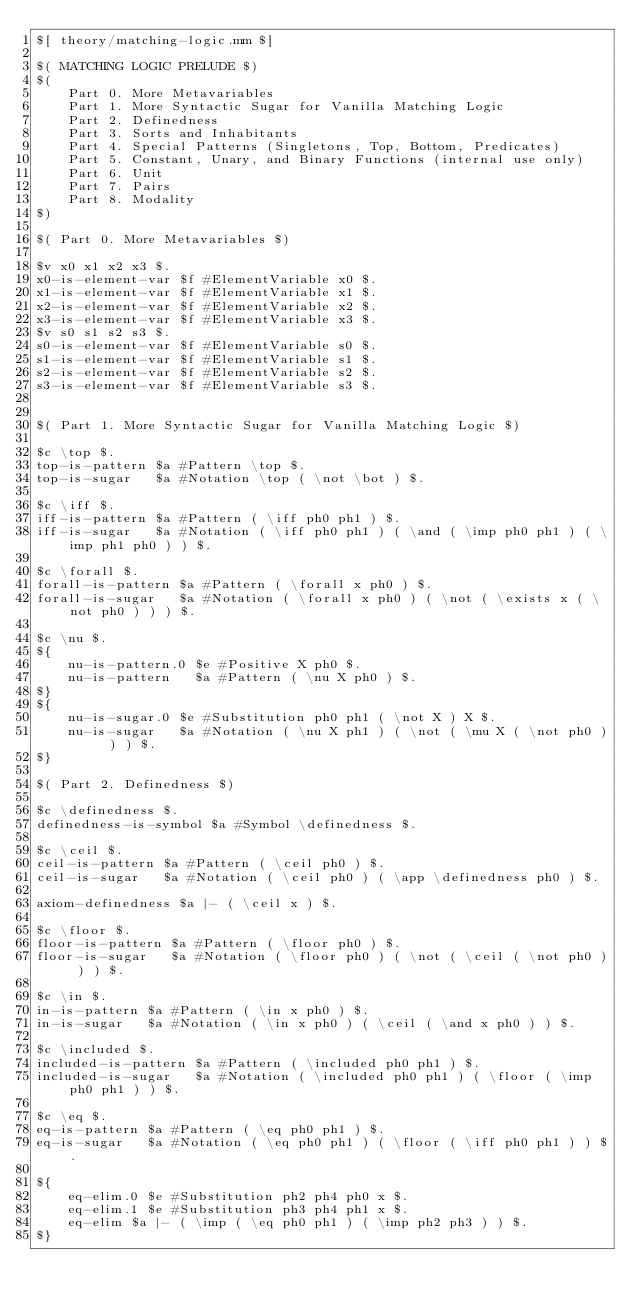<code> <loc_0><loc_0><loc_500><loc_500><_ObjectiveC_>$[ theory/matching-logic.mm $]

$( MATCHING LOGIC PRELUDE $)
$(
    Part 0. More Metavariables
    Part 1. More Syntactic Sugar for Vanilla Matching Logic
    Part 2. Definedness
    Part 3. Sorts and Inhabitants
    Part 4. Special Patterns (Singletons, Top, Bottom, Predicates)
    Part 5. Constant, Unary, and Binary Functions (internal use only)
    Part 6. Unit
    Part 7. Pairs
    Part 8. Modality
$)

$( Part 0. More Metavariables $)

$v x0 x1 x2 x3 $.
x0-is-element-var $f #ElementVariable x0 $.
x1-is-element-var $f #ElementVariable x1 $.
x2-is-element-var $f #ElementVariable x2 $.
x3-is-element-var $f #ElementVariable x3 $.
$v s0 s1 s2 s3 $.
s0-is-element-var $f #ElementVariable s0 $.
s1-is-element-var $f #ElementVariable s1 $.
s2-is-element-var $f #ElementVariable s2 $.
s3-is-element-var $f #ElementVariable s3 $.


$( Part 1. More Syntactic Sugar for Vanilla Matching Logic $)

$c \top $.
top-is-pattern $a #Pattern \top $.
top-is-sugar   $a #Notation \top ( \not \bot ) $.

$c \iff $.
iff-is-pattern $a #Pattern ( \iff ph0 ph1 ) $.
iff-is-sugar   $a #Notation ( \iff ph0 ph1 ) ( \and ( \imp ph0 ph1 ) ( \imp ph1 ph0 ) ) $.

$c \forall $.
forall-is-pattern $a #Pattern ( \forall x ph0 ) $.
forall-is-sugar   $a #Notation ( \forall x ph0 ) ( \not ( \exists x ( \not ph0 ) ) ) $.

$c \nu $.
${
    nu-is-pattern.0 $e #Positive X ph0 $.
    nu-is-pattern   $a #Pattern ( \nu X ph0 ) $.
$}
${
    nu-is-sugar.0 $e #Substitution ph0 ph1 ( \not X ) X $.
    nu-is-sugar   $a #Notation ( \nu X ph1 ) ( \not ( \mu X ( \not ph0 ) ) ) $.
$}

$( Part 2. Definedness $)

$c \definedness $.
definedness-is-symbol $a #Symbol \definedness $.

$c \ceil $.
ceil-is-pattern $a #Pattern ( \ceil ph0 ) $.
ceil-is-sugar   $a #Notation ( \ceil ph0 ) ( \app \definedness ph0 ) $.

axiom-definedness $a |- ( \ceil x ) $.

$c \floor $.
floor-is-pattern $a #Pattern ( \floor ph0 ) $.
floor-is-sugar   $a #Notation ( \floor ph0 ) ( \not ( \ceil ( \not ph0 ) ) ) $.

$c \in $.
in-is-pattern $a #Pattern ( \in x ph0 ) $.
in-is-sugar   $a #Notation ( \in x ph0 ) ( \ceil ( \and x ph0 ) ) $.

$c \included $.
included-is-pattern $a #Pattern ( \included ph0 ph1 ) $.
included-is-sugar   $a #Notation ( \included ph0 ph1 ) ( \floor ( \imp ph0 ph1 ) ) $.

$c \eq $.
eq-is-pattern $a #Pattern ( \eq ph0 ph1 ) $.
eq-is-sugar   $a #Notation ( \eq ph0 ph1 ) ( \floor ( \iff ph0 ph1 ) ) $.

${
    eq-elim.0 $e #Substitution ph2 ph4 ph0 x $.
    eq-elim.1 $e #Substitution ph3 ph4 ph1 x $.
    eq-elim $a |- ( \imp ( \eq ph0 ph1 ) ( \imp ph2 ph3 ) ) $.
$}
</code> 